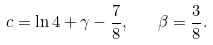<formula> <loc_0><loc_0><loc_500><loc_500>c = \ln 4 + \gamma - \frac { 7 } { 8 } , \quad \beta = \frac { 3 } { 8 } { . }</formula> 